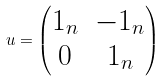Convert formula to latex. <formula><loc_0><loc_0><loc_500><loc_500>u = \begin{pmatrix} 1 _ { n } & - 1 _ { n } \\ 0 & 1 _ { n } \end{pmatrix}</formula> 